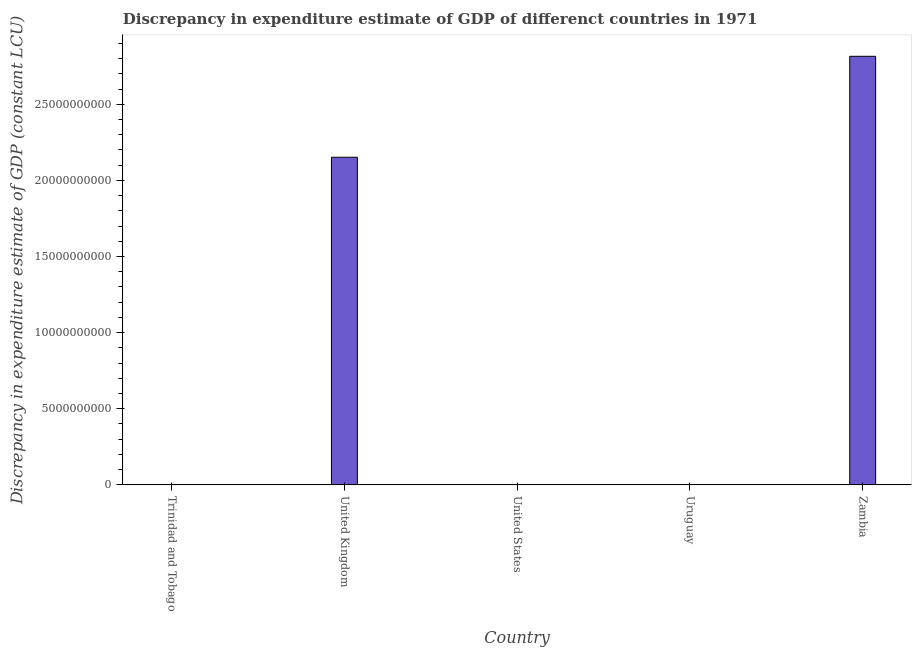Does the graph contain any zero values?
Your answer should be compact. Yes. Does the graph contain grids?
Provide a short and direct response. No. What is the title of the graph?
Make the answer very short. Discrepancy in expenditure estimate of GDP of differenct countries in 1971. What is the label or title of the Y-axis?
Your response must be concise. Discrepancy in expenditure estimate of GDP (constant LCU). Across all countries, what is the maximum discrepancy in expenditure estimate of gdp?
Your answer should be very brief. 2.82e+1. In which country was the discrepancy in expenditure estimate of gdp maximum?
Offer a very short reply. Zambia. What is the sum of the discrepancy in expenditure estimate of gdp?
Provide a short and direct response. 4.97e+1. What is the difference between the discrepancy in expenditure estimate of gdp in United Kingdom and Zambia?
Make the answer very short. -6.63e+09. What is the average discrepancy in expenditure estimate of gdp per country?
Make the answer very short. 9.93e+09. In how many countries, is the discrepancy in expenditure estimate of gdp greater than 15000000000 LCU?
Ensure brevity in your answer.  2. What is the ratio of the discrepancy in expenditure estimate of gdp in United Kingdom to that in Zambia?
Your answer should be very brief. 0.76. Is the discrepancy in expenditure estimate of gdp in United Kingdom less than that in Zambia?
Provide a succinct answer. Yes. Is the sum of the discrepancy in expenditure estimate of gdp in United Kingdom and Zambia greater than the maximum discrepancy in expenditure estimate of gdp across all countries?
Offer a terse response. Yes. What is the difference between the highest and the lowest discrepancy in expenditure estimate of gdp?
Give a very brief answer. 2.82e+1. In how many countries, is the discrepancy in expenditure estimate of gdp greater than the average discrepancy in expenditure estimate of gdp taken over all countries?
Provide a succinct answer. 2. How many bars are there?
Offer a very short reply. 2. Are all the bars in the graph horizontal?
Give a very brief answer. No. What is the difference between two consecutive major ticks on the Y-axis?
Keep it short and to the point. 5.00e+09. Are the values on the major ticks of Y-axis written in scientific E-notation?
Your answer should be compact. No. What is the Discrepancy in expenditure estimate of GDP (constant LCU) in United Kingdom?
Offer a terse response. 2.15e+1. What is the Discrepancy in expenditure estimate of GDP (constant LCU) in Uruguay?
Your response must be concise. 0. What is the Discrepancy in expenditure estimate of GDP (constant LCU) of Zambia?
Provide a short and direct response. 2.82e+1. What is the difference between the Discrepancy in expenditure estimate of GDP (constant LCU) in United Kingdom and Zambia?
Your answer should be compact. -6.63e+09. What is the ratio of the Discrepancy in expenditure estimate of GDP (constant LCU) in United Kingdom to that in Zambia?
Ensure brevity in your answer.  0.76. 